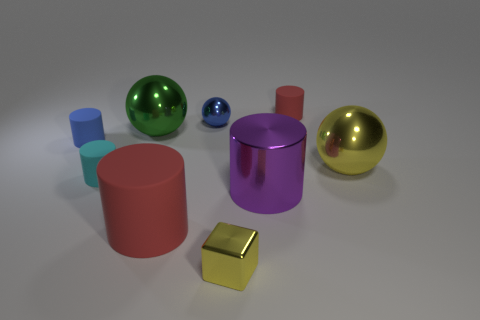There is a purple metallic thing that is the same shape as the large red thing; what size is it?
Your answer should be compact. Large. What number of large things are either gray cylinders or blue cylinders?
Keep it short and to the point. 0. Do the red cylinder in front of the large purple metallic thing and the blue object in front of the green metal sphere have the same material?
Give a very brief answer. Yes. What is the material of the large purple cylinder that is on the left side of the yellow metal sphere?
Your answer should be very brief. Metal. What number of metal objects are either big brown cylinders or big green objects?
Provide a succinct answer. 1. There is a matte object that is behind the small metallic object that is left of the small shiny block; what is its color?
Provide a succinct answer. Red. Are the green thing and the yellow object to the right of the purple shiny cylinder made of the same material?
Offer a very short reply. Yes. What color is the rubber cylinder to the right of the red thing in front of the red matte cylinder that is behind the small blue sphere?
Your response must be concise. Red. Is there any other thing that has the same shape as the big purple metal thing?
Provide a succinct answer. Yes. Are there more tiny metal blocks than big gray cylinders?
Your answer should be compact. Yes. 